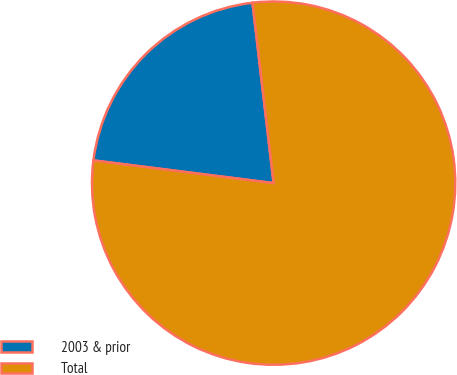Convert chart to OTSL. <chart><loc_0><loc_0><loc_500><loc_500><pie_chart><fcel>2003 & prior<fcel>Total<nl><fcel>21.15%<fcel>78.85%<nl></chart> 